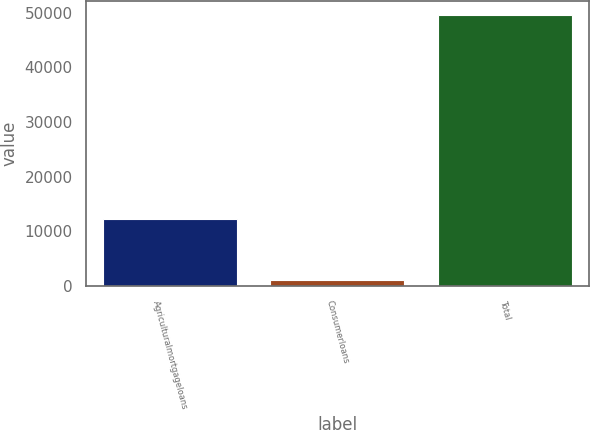Convert chart to OTSL. <chart><loc_0><loc_0><loc_500><loc_500><bar_chart><fcel>Agriculturalmortgageloans<fcel>Consumerloans<fcel>Total<nl><fcel>12295<fcel>1164<fcel>49656<nl></chart> 